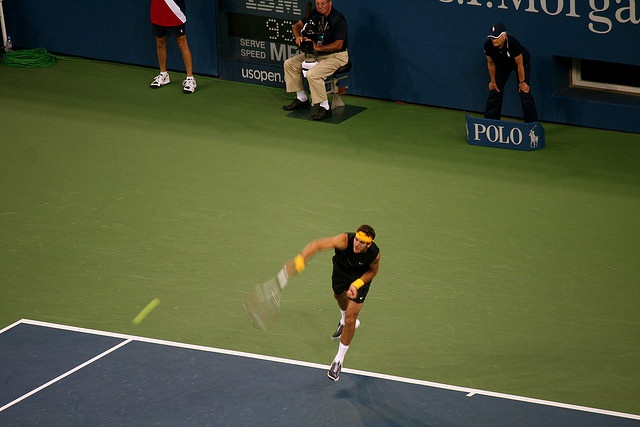Describe the objects in this image and their specific colors. I can see people in gray, black, olive, and brown tones, people in gray, black, tan, and maroon tones, people in gray, black, maroon, and brown tones, people in gray, maroon, black, lightgray, and darkgray tones, and tennis racket in gray and olive tones in this image. 